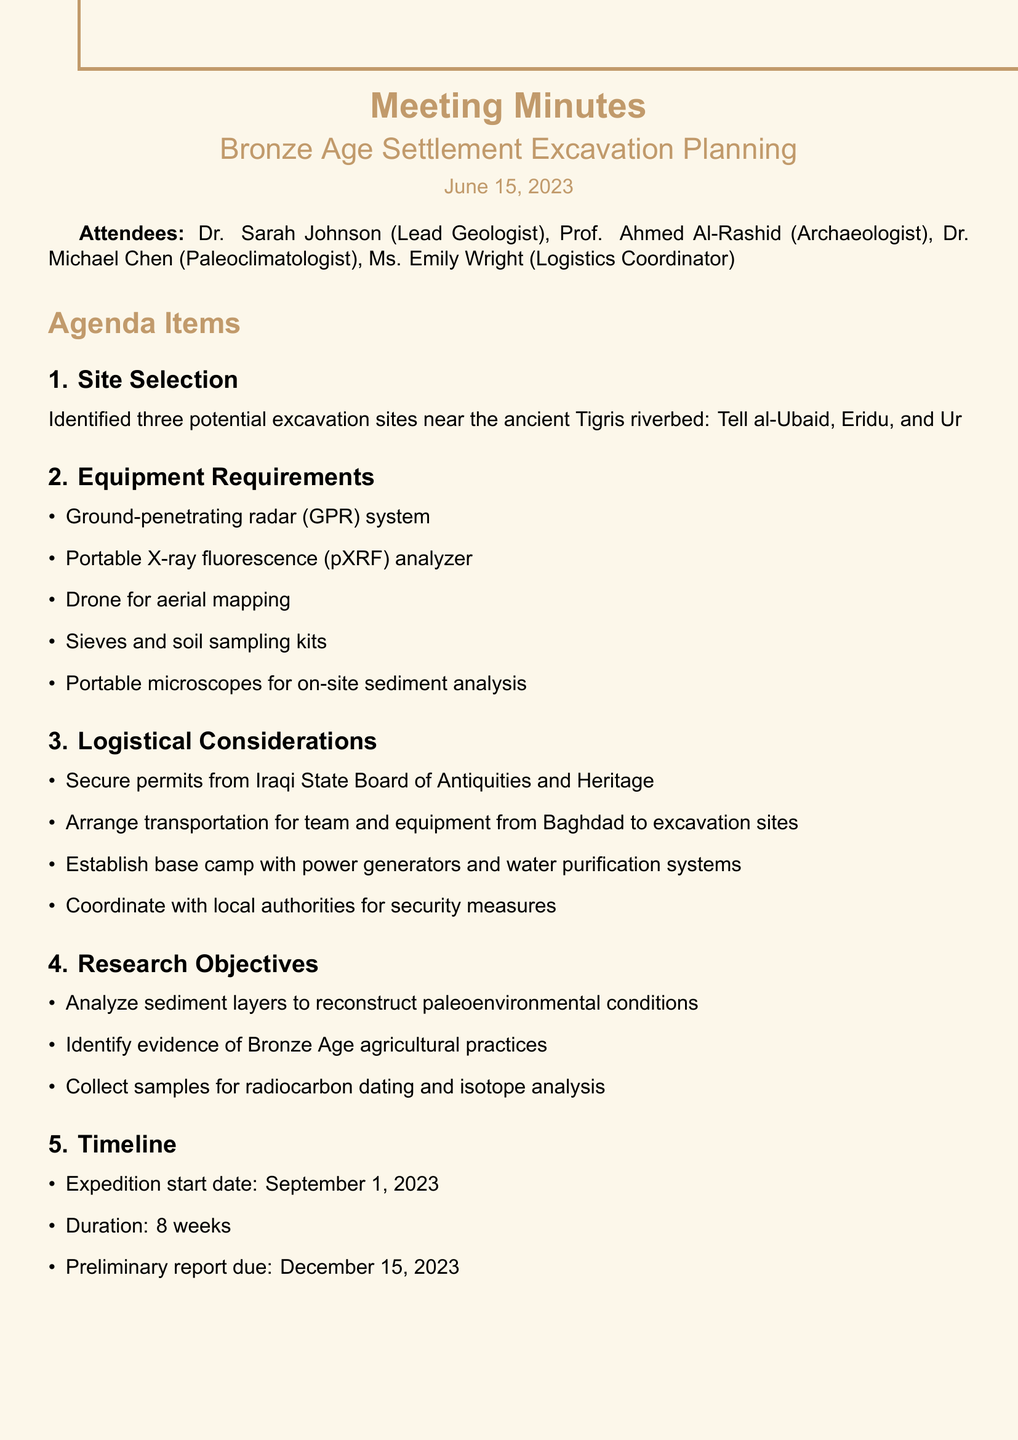What is the meeting title? The meeting title is stated at the top of the document, identifying the focus of the meeting.
Answer: Bronze Age Settlement Excavation Planning What is the date of the meeting? The date of the meeting is indicated directly after the title, providing context for the discussion.
Answer: June 15, 2023 Who is the Lead Geologist? The attendees section lists each participant along with their roles, making it easy to identify key individuals.
Answer: Dr. Sarah Johnson What equipment is required for the expedition? The Equipment Requirements section enumerates the tools and devices needed, which are crucial for the excavation process.
Answer: Ground-penetrating radar (GPR) system What are the identified excavation sites? The Site Selection section specifies the potential sites that have been noted for excavation, which is essential for planning.
Answer: Tell al-Ubaid, Eridu, and Ur What is the expedition start date? The Timeline section details important dates relevant to the expedition's schedule.
Answer: September 1, 2023 Who is responsible for arranging logistics and accommodation? The Action Items section outlines specific responsibilities assigned to team members, clarifying actions needed before the expedition.
Answer: Ms. Wright What is one of the research objectives? The Research Objectives section lists the goals and aims of the upcoming fieldwork, important for focusing the excavation efforts.
Answer: Analyze sediment layers to reconstruct paleoenvironmental conditions How long is the expedition planned to last? The Timeline section provides information about the duration of the expedition, important for logistical planning.
Answer: 8 weeks 